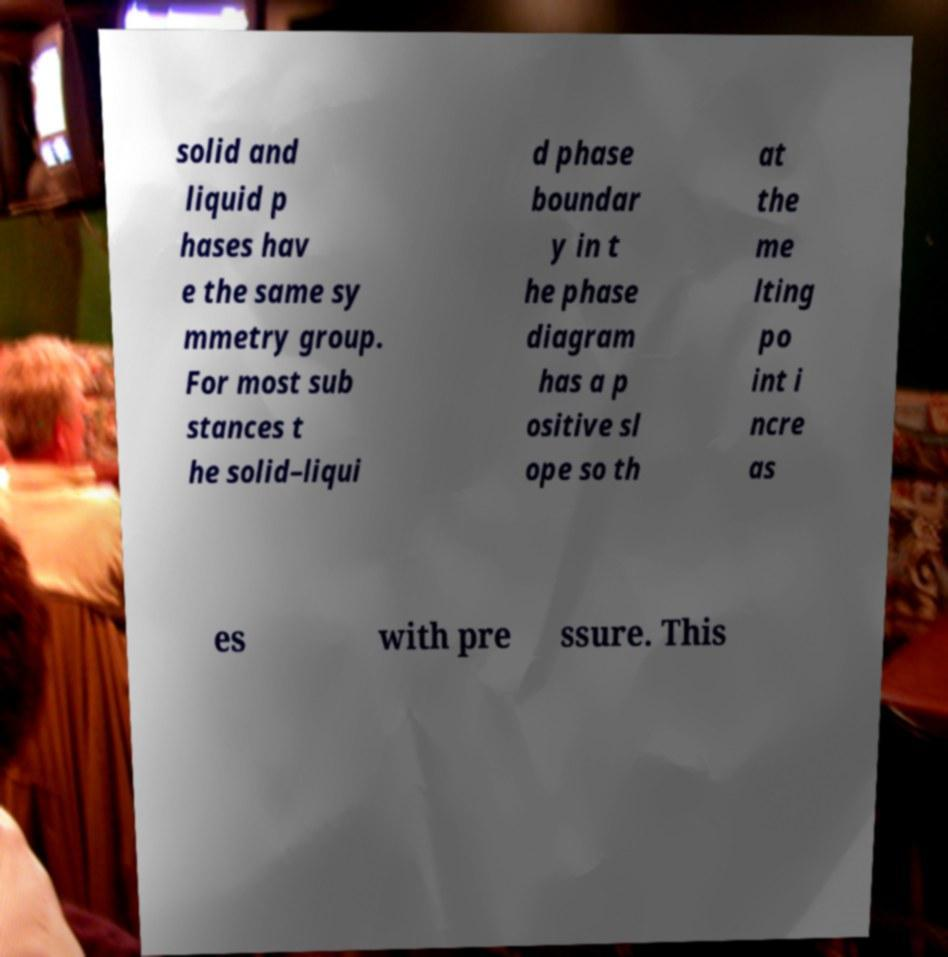Can you accurately transcribe the text from the provided image for me? solid and liquid p hases hav e the same sy mmetry group. For most sub stances t he solid–liqui d phase boundar y in t he phase diagram has a p ositive sl ope so th at the me lting po int i ncre as es with pre ssure. This 